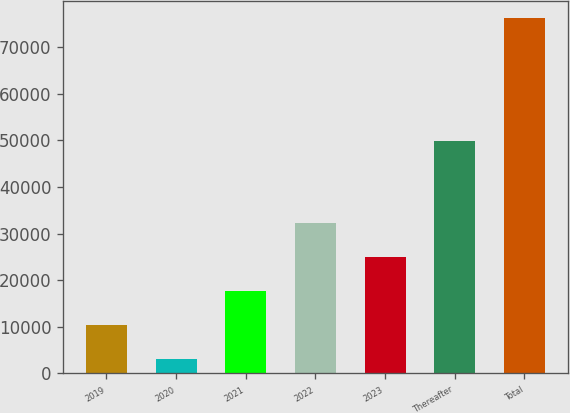<chart> <loc_0><loc_0><loc_500><loc_500><bar_chart><fcel>2019<fcel>2020<fcel>2021<fcel>2022<fcel>2023<fcel>Thereafter<fcel>Total<nl><fcel>10365.7<fcel>3052<fcel>17679.4<fcel>32306.8<fcel>24993.1<fcel>49961<fcel>76189<nl></chart> 